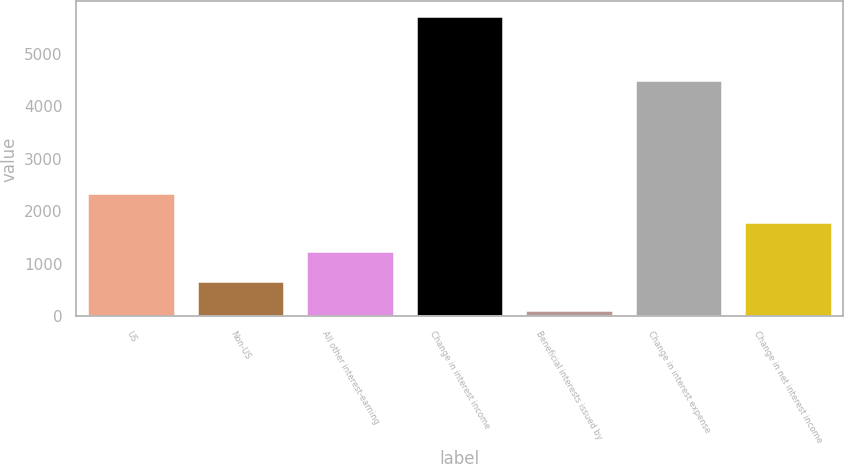Convert chart to OTSL. <chart><loc_0><loc_0><loc_500><loc_500><bar_chart><fcel>US<fcel>Non-US<fcel>All other interest-earning<fcel>Change in interest income<fcel>Beneficial interests issued by<fcel>Change in interest expense<fcel>Change in net interest income<nl><fcel>2355<fcel>679.5<fcel>1238<fcel>5706<fcel>121<fcel>4490<fcel>1796.5<nl></chart> 